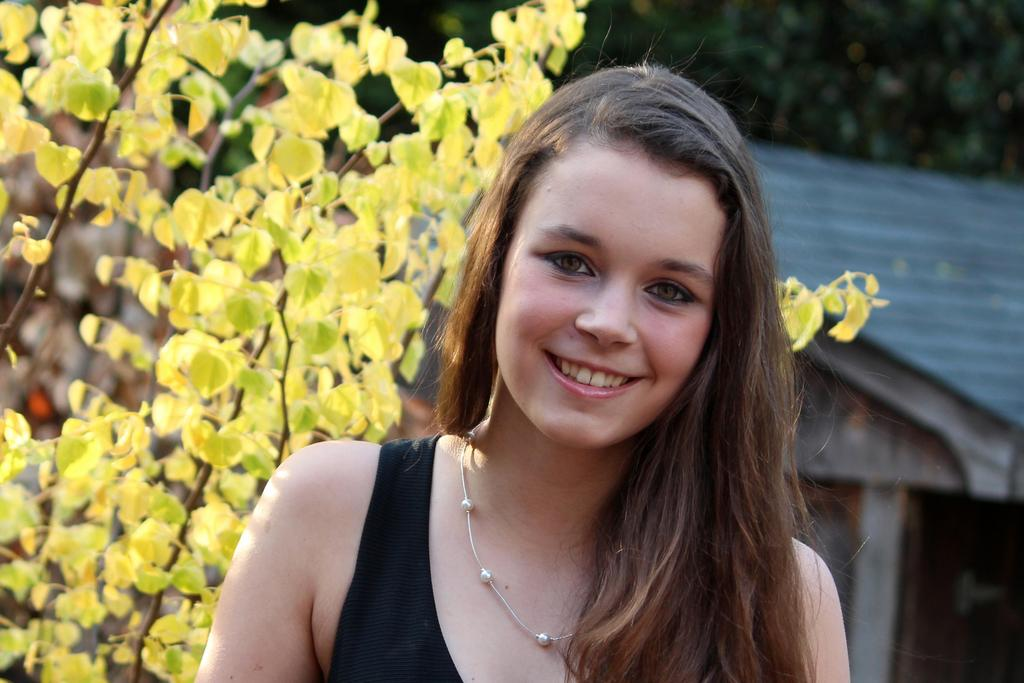What is the main subject of the image? The main subject of the image is a woman. What is the woman doing in the image? The woman is smiling in the image. What can be seen in the background of the image? There are trees and a house in the background of the image. What type of cracker is the woman holding in the image? There is no cracker present in the image, and the woman is not holding anything. What type of humor is being displayed by the woman in the image? There is no specific humor being displayed by the woman in the image; she is simply smiling. 